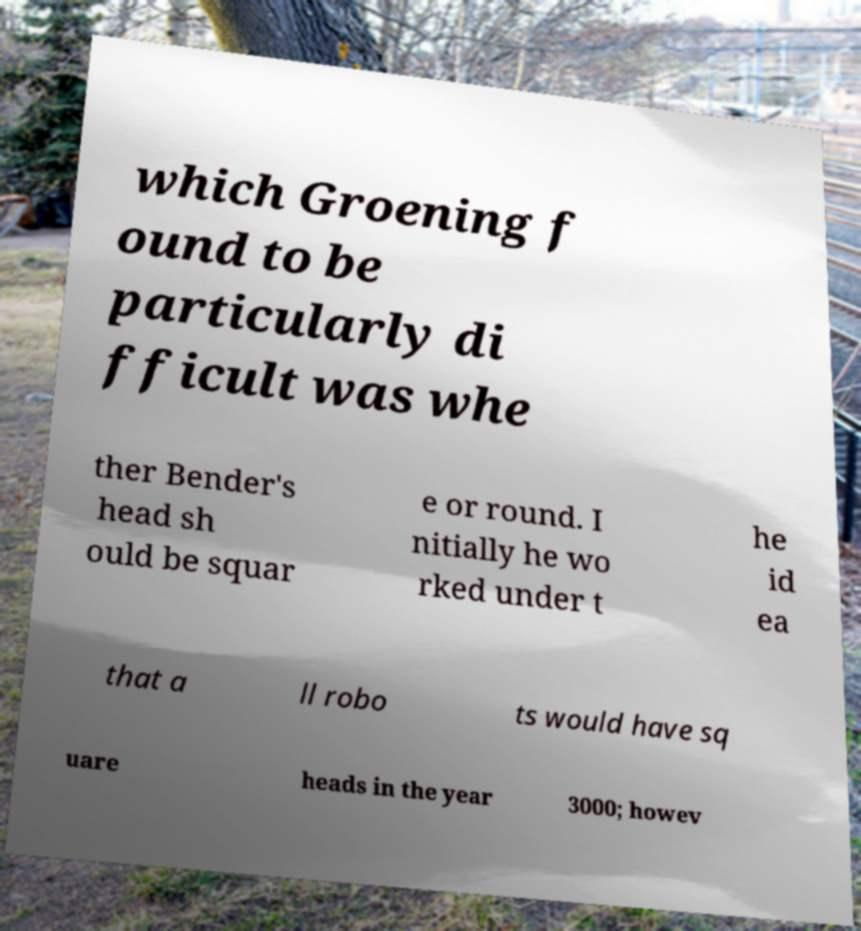What messages or text are displayed in this image? I need them in a readable, typed format. which Groening f ound to be particularly di fficult was whe ther Bender's head sh ould be squar e or round. I nitially he wo rked under t he id ea that a ll robo ts would have sq uare heads in the year 3000; howev 